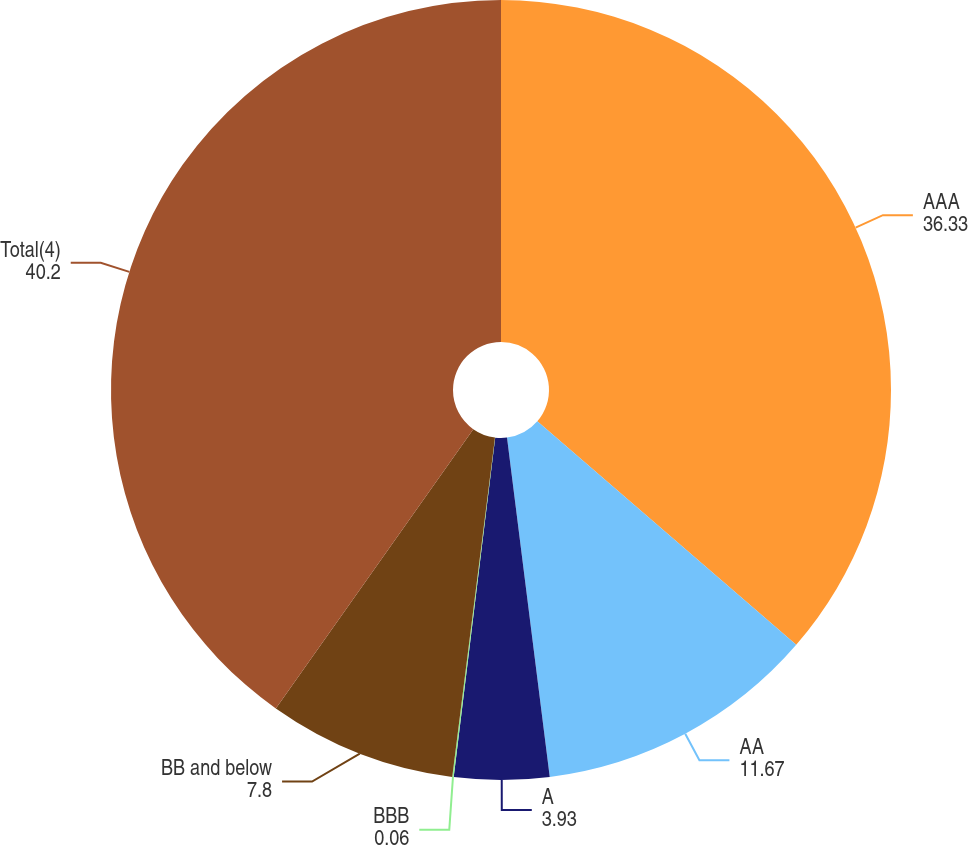Convert chart to OTSL. <chart><loc_0><loc_0><loc_500><loc_500><pie_chart><fcel>AAA<fcel>AA<fcel>A<fcel>BBB<fcel>BB and below<fcel>Total(4)<nl><fcel>36.33%<fcel>11.67%<fcel>3.93%<fcel>0.06%<fcel>7.8%<fcel>40.2%<nl></chart> 